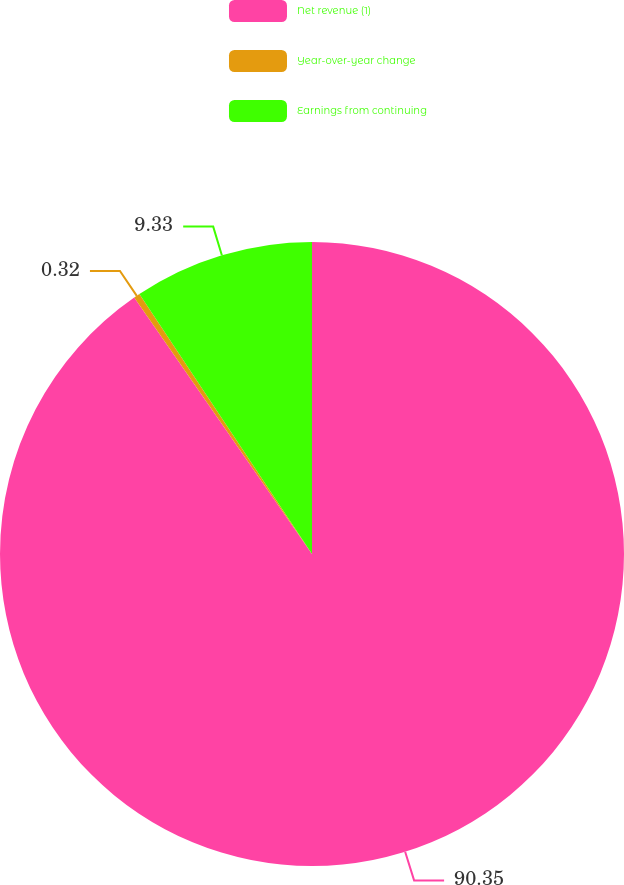Convert chart to OTSL. <chart><loc_0><loc_0><loc_500><loc_500><pie_chart><fcel>Net revenue (1)<fcel>Year-over-year change<fcel>Earnings from continuing<nl><fcel>90.35%<fcel>0.32%<fcel>9.33%<nl></chart> 